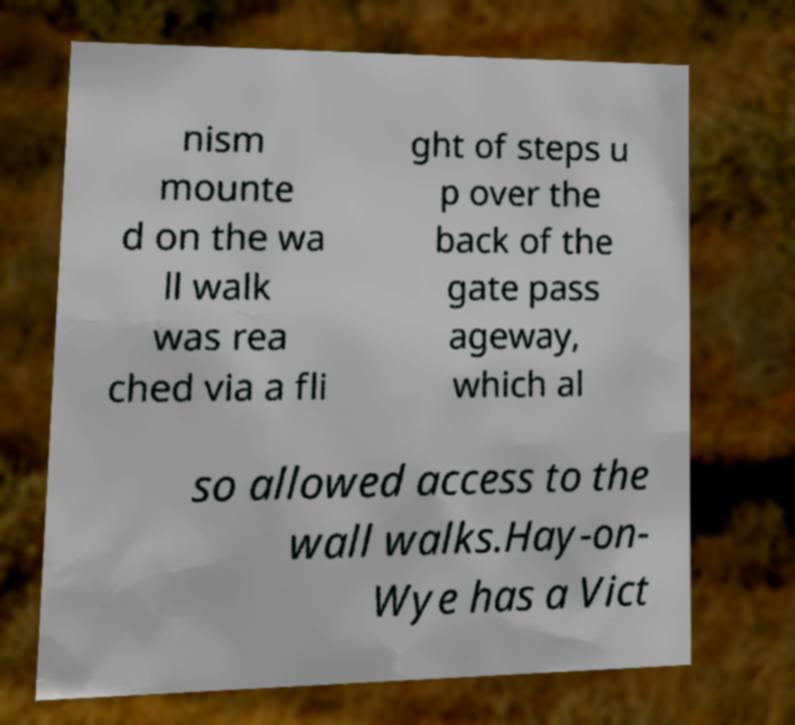Please read and relay the text visible in this image. What does it say? nism mounte d on the wa ll walk was rea ched via a fli ght of steps u p over the back of the gate pass ageway, which al so allowed access to the wall walks.Hay-on- Wye has a Vict 